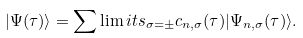<formula> <loc_0><loc_0><loc_500><loc_500>| \Psi ( \tau ) \rangle = \sum \lim i t s _ { \sigma = \pm } c _ { n , \sigma } ( \tau ) | \Psi _ { n , \sigma } ( \tau ) \rangle .</formula> 